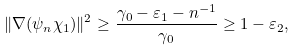<formula> <loc_0><loc_0><loc_500><loc_500>\| \nabla ( \psi _ { n } \chi _ { 1 } ) \| ^ { 2 } \geq \frac { \gamma _ { 0 } - \varepsilon _ { 1 } - n ^ { - 1 } } { \gamma _ { 0 } } \geq 1 - \varepsilon _ { 2 } ,</formula> 